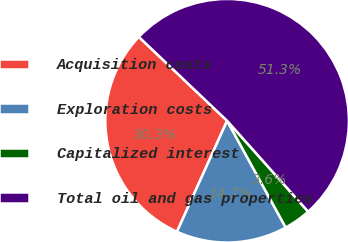<chart> <loc_0><loc_0><loc_500><loc_500><pie_chart><fcel>Acquisition costs<fcel>Exploration costs<fcel>Capitalized interest<fcel>Total oil and gas properties<nl><fcel>30.34%<fcel>14.75%<fcel>3.6%<fcel>51.32%<nl></chart> 